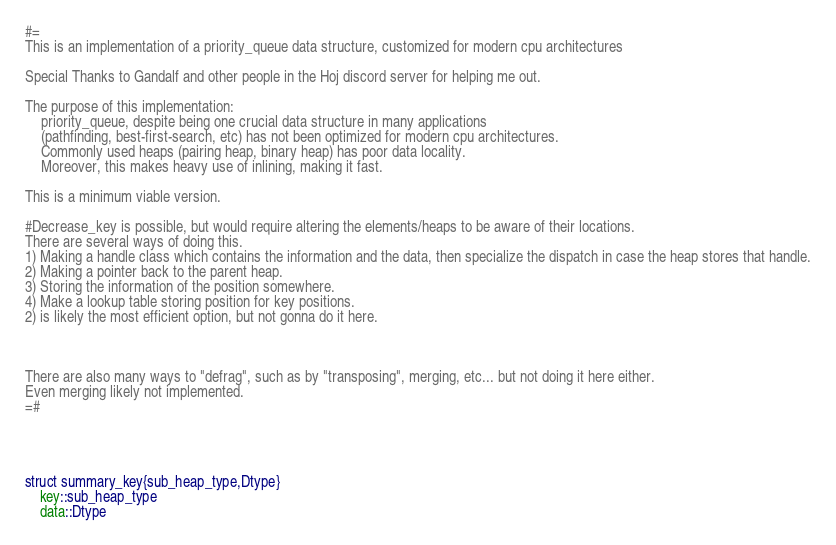Convert code to text. <code><loc_0><loc_0><loc_500><loc_500><_Julia_>#= 
This is an implementation of a priority_queue data structure, customized for modern cpu architectures

Special Thanks to Gandalf and other people in the Hoj discord server for helping me out.

The purpose of this implementation:
    priority_queue, despite being one crucial data structure in many applications 
    (pathfinding, best-first-search, etc) has not been optimized for modern cpu architectures.
    Commonly used heaps (pairing heap, binary heap) has poor data locality. 
    Moreover, this makes heavy use of inlining, making it fast.

This is a minimum viable version. 

#Decrease_key is possible, but would require altering the elements/heaps to be aware of their locations.
There are several ways of doing this.
1) Making a handle class which contains the information and the data, then specialize the dispatch in case the heap stores that handle.
2) Making a pointer back to the parent heap. 
3) Storing the information of the position somewhere.
4) Make a lookup table storing position for key positions.
2) is likely the most efficient option, but not gonna do it here.



There are also many ways to "defrag", such as by "transposing", merging, etc... but not doing it here either.
Even merging likely not implemented.
=#




struct summary_key{sub_heap_type,Dtype}
    key::sub_heap_type
    data::Dtype</code> 